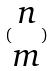<formula> <loc_0><loc_0><loc_500><loc_500>( \begin{matrix} n \\ m \end{matrix} )</formula> 